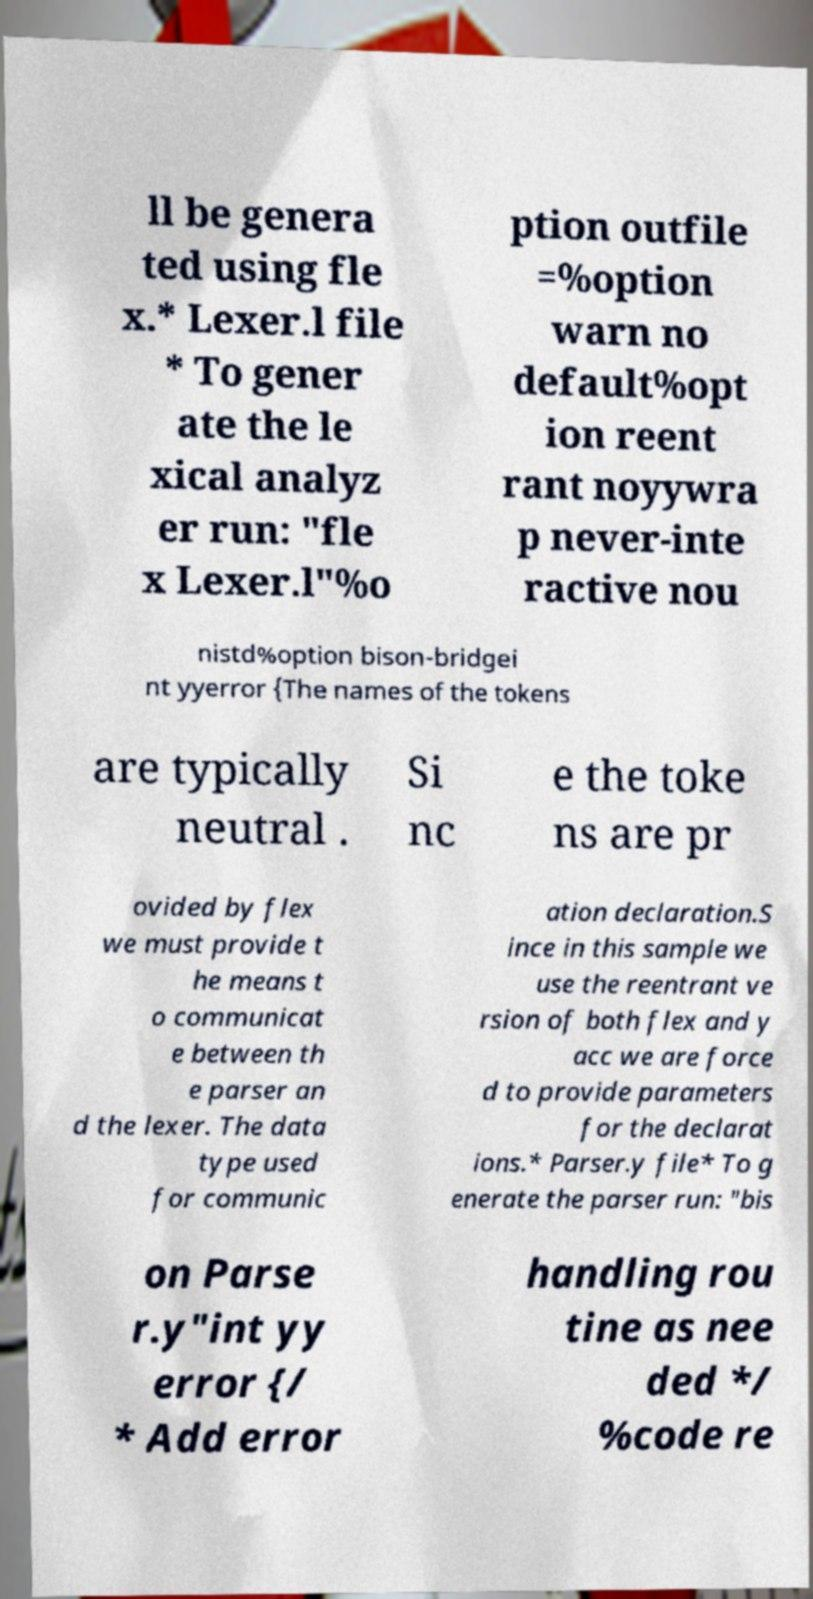Could you extract and type out the text from this image? ll be genera ted using fle x.* Lexer.l file * To gener ate the le xical analyz er run: "fle x Lexer.l"%o ption outfile =%option warn no default%opt ion reent rant noyywra p never-inte ractive nou nistd%option bison-bridgei nt yyerror {The names of the tokens are typically neutral . Si nc e the toke ns are pr ovided by flex we must provide t he means t o communicat e between th e parser an d the lexer. The data type used for communic ation declaration.S ince in this sample we use the reentrant ve rsion of both flex and y acc we are force d to provide parameters for the declarat ions.* Parser.y file* To g enerate the parser run: "bis on Parse r.y"int yy error {/ * Add error handling rou tine as nee ded */ %code re 